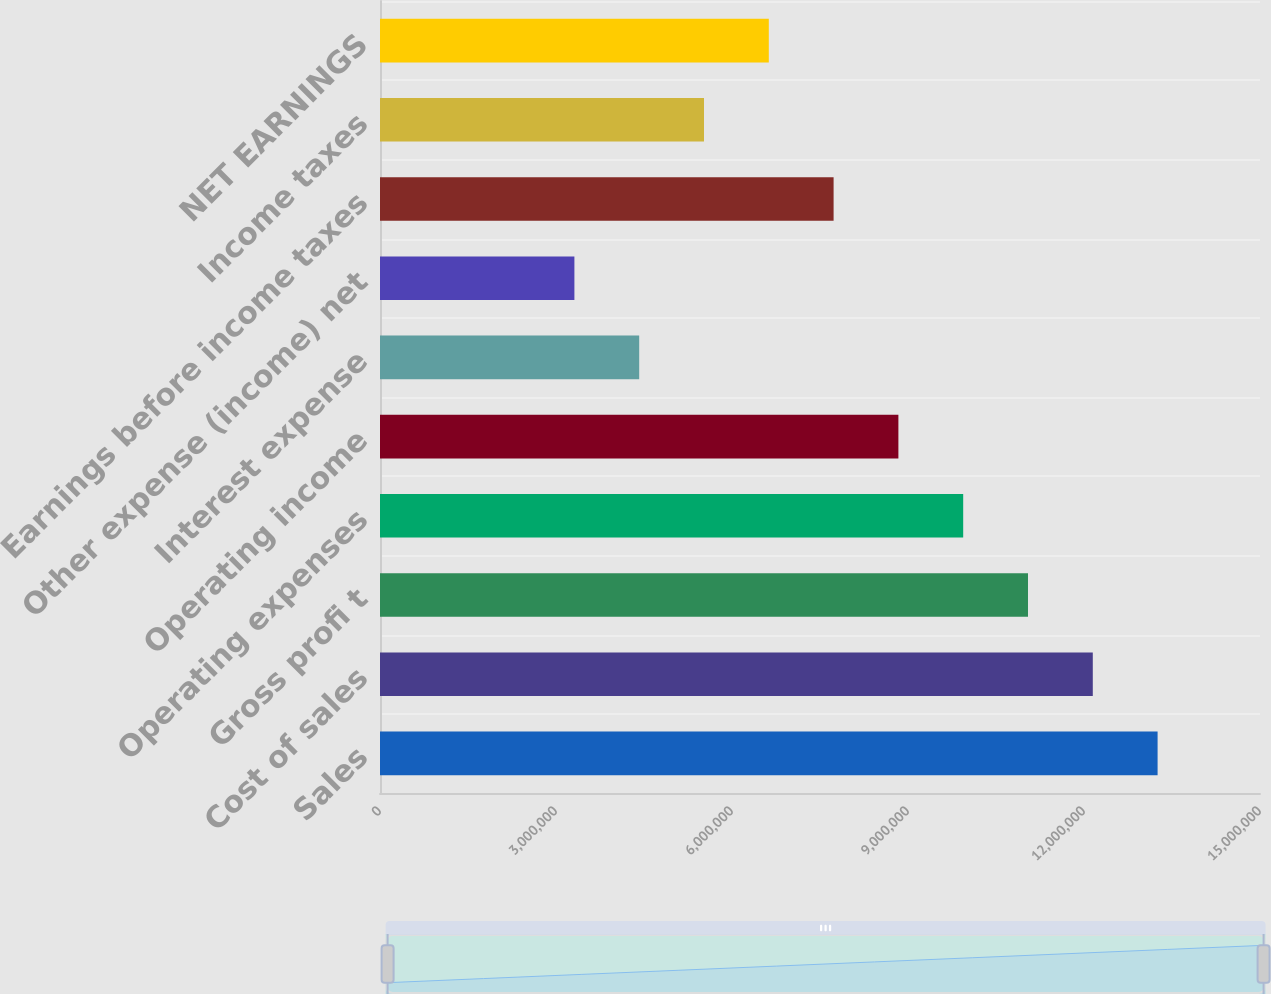Convert chart. <chart><loc_0><loc_0><loc_500><loc_500><bar_chart><fcel>Sales<fcel>Cost of sales<fcel>Gross profi t<fcel>Operating expenses<fcel>Operating income<fcel>Interest expense<fcel>Other expense (income) net<fcel>Earnings before income taxes<fcel>Income taxes<fcel>NET EARNINGS<nl><fcel>1.32545e+07<fcel>1.21499e+07<fcel>1.10454e+07<fcel>9.94084e+06<fcel>8.83631e+06<fcel>4.41815e+06<fcel>3.31361e+06<fcel>7.73177e+06<fcel>5.52269e+06<fcel>6.62723e+06<nl></chart> 